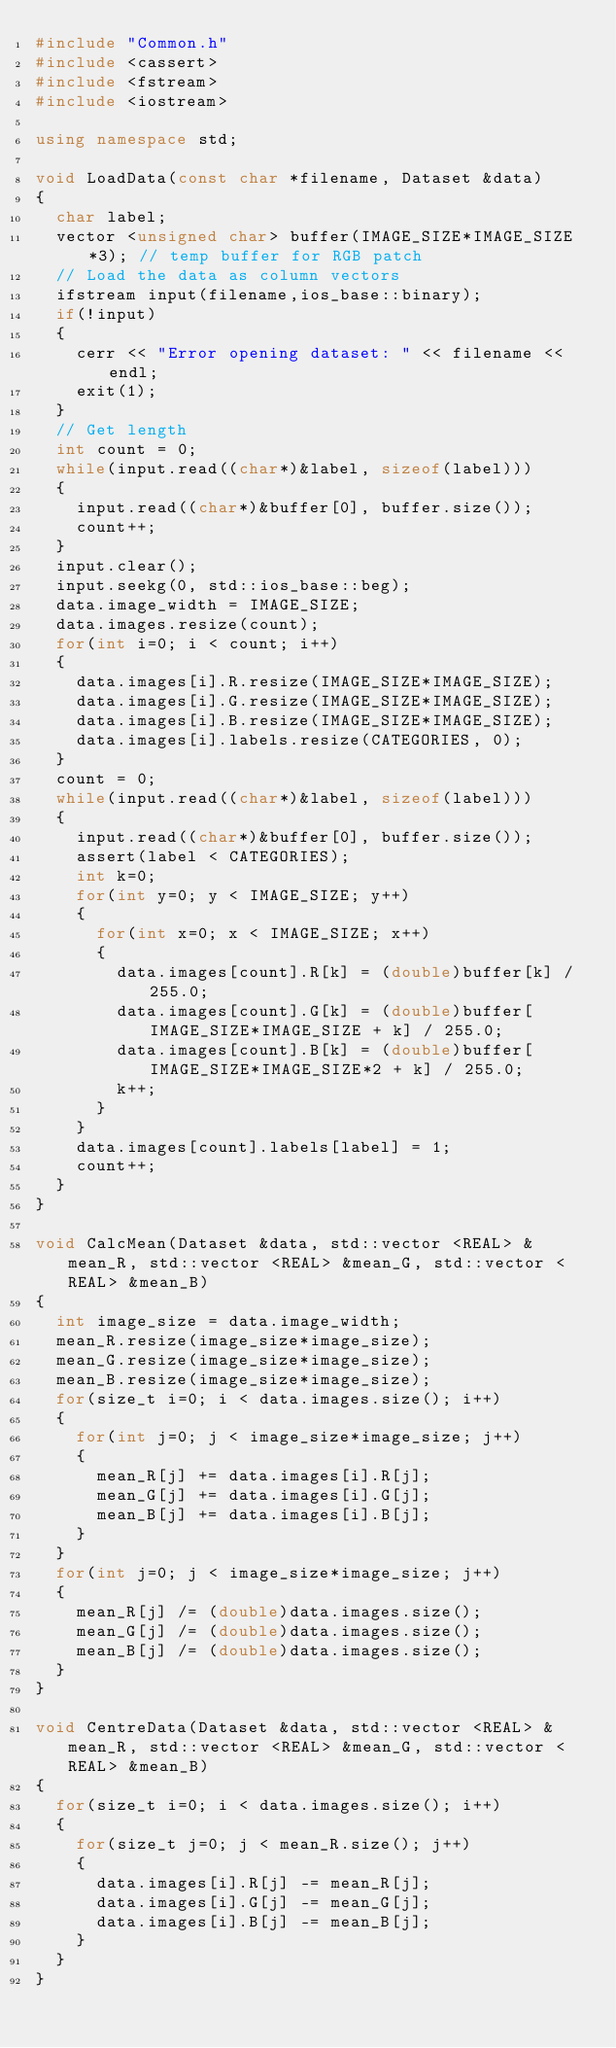<code> <loc_0><loc_0><loc_500><loc_500><_C++_>#include "Common.h"
#include <cassert>
#include <fstream>
#include <iostream>

using namespace std;

void LoadData(const char *filename, Dataset &data)
{
	char label;
	vector <unsigned char> buffer(IMAGE_SIZE*IMAGE_SIZE*3); // temp buffer for RGB patch
	// Load the data as column vectors
	ifstream input(filename,ios_base::binary);
	if(!input)
	{
		cerr << "Error opening dataset: " << filename << endl;
		exit(1);
	}
	// Get length
	int count = 0;
	while(input.read((char*)&label, sizeof(label)))
	{
		input.read((char*)&buffer[0], buffer.size());
		count++;
	}
	input.clear();
	input.seekg(0, std::ios_base::beg);
	data.image_width = IMAGE_SIZE;
	data.images.resize(count);
	for(int i=0; i < count; i++)
	{
		data.images[i].R.resize(IMAGE_SIZE*IMAGE_SIZE);
		data.images[i].G.resize(IMAGE_SIZE*IMAGE_SIZE);
		data.images[i].B.resize(IMAGE_SIZE*IMAGE_SIZE);
		data.images[i].labels.resize(CATEGORIES, 0);
	}
	count = 0;
	while(input.read((char*)&label, sizeof(label)))
	{
		input.read((char*)&buffer[0], buffer.size());
		assert(label < CATEGORIES);
		int k=0;
		for(int y=0; y < IMAGE_SIZE; y++)
		{
			for(int x=0; x < IMAGE_SIZE; x++)
			{
				data.images[count].R[k] = (double)buffer[k] / 255.0;
				data.images[count].G[k] = (double)buffer[IMAGE_SIZE*IMAGE_SIZE + k] / 255.0;
				data.images[count].B[k] = (double)buffer[IMAGE_SIZE*IMAGE_SIZE*2 + k] / 255.0;
				k++;
			}
		}
		data.images[count].labels[label] = 1;
		count++;
	}
}

void CalcMean(Dataset &data, std::vector <REAL> &mean_R, std::vector <REAL> &mean_G, std::vector <REAL> &mean_B)
{
	int image_size = data.image_width;
	mean_R.resize(image_size*image_size);
	mean_G.resize(image_size*image_size);
	mean_B.resize(image_size*image_size);
	for(size_t i=0; i < data.images.size(); i++)
	{
		for(int j=0; j < image_size*image_size; j++)
		{
			mean_R[j] += data.images[i].R[j];
			mean_G[j] += data.images[i].G[j];
			mean_B[j] += data.images[i].B[j];
		}
	}
	for(int j=0; j < image_size*image_size; j++)
	{
		mean_R[j] /= (double)data.images.size();
		mean_G[j] /= (double)data.images.size();
		mean_B[j] /= (double)data.images.size();
	}
}

void CentreData(Dataset &data, std::vector <REAL> &mean_R, std::vector <REAL> &mean_G, std::vector <REAL> &mean_B)
{
	for(size_t i=0; i < data.images.size(); i++)
	{
		for(size_t j=0; j < mean_R.size(); j++)
		{
			data.images[i].R[j] -= mean_R[j];
			data.images[i].G[j] -= mean_G[j];
			data.images[i].B[j] -= mean_B[j];
		}
	}
}
</code> 